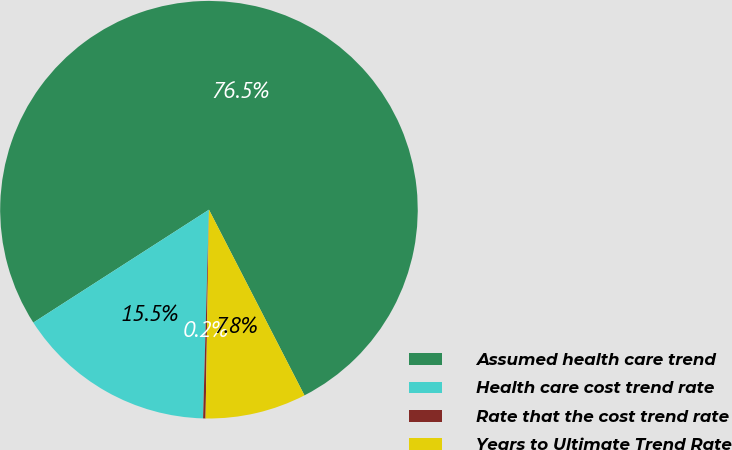Convert chart. <chart><loc_0><loc_0><loc_500><loc_500><pie_chart><fcel>Assumed health care trend<fcel>Health care cost trend rate<fcel>Rate that the cost trend rate<fcel>Years to Ultimate Trend Rate<nl><fcel>76.53%<fcel>15.46%<fcel>0.19%<fcel>7.82%<nl></chart> 